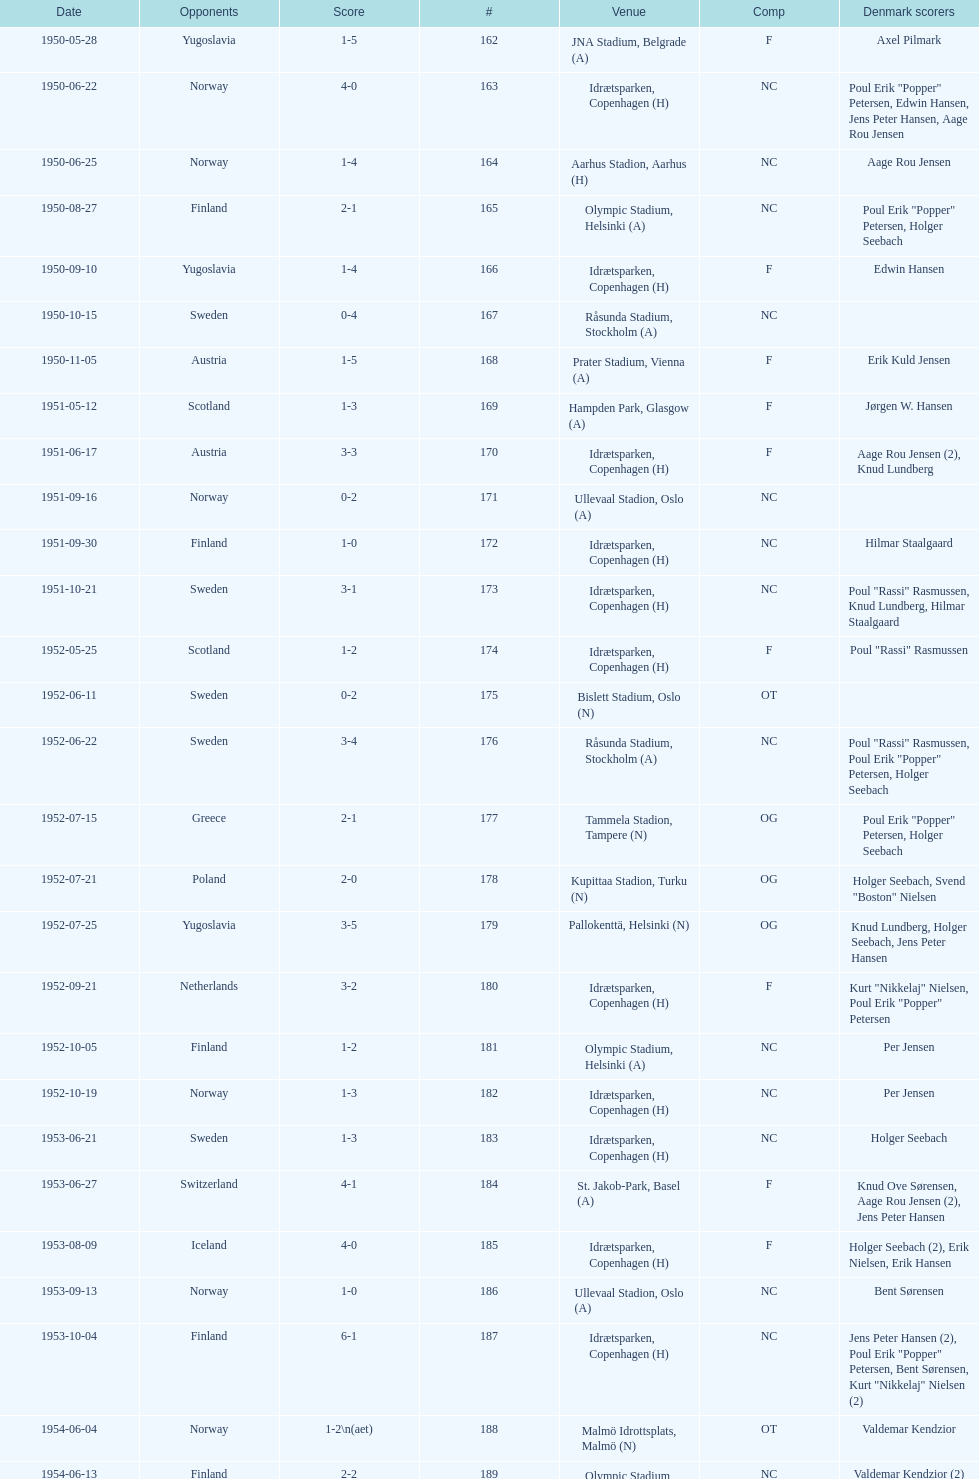What are the number of times nc appears under the comp column? 32. 